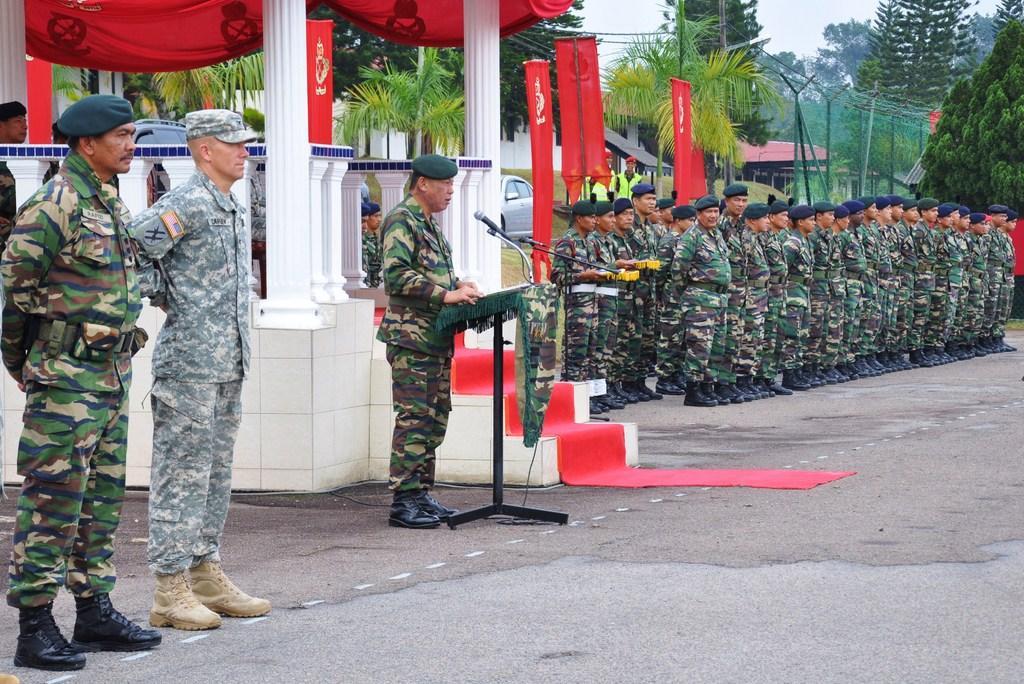In one or two sentences, can you explain what this image depicts? On the left side of the image there are two men standing. And there is a man standing in front of the podium with a mic. Behind him there are pillars, steps with red carpet. On the right side of the image there are few men standing with uniforms, shoes and caps on their heads. Behind them there are many trees, electrical poles with wires, red flags and also there is a car and a house with roof. 